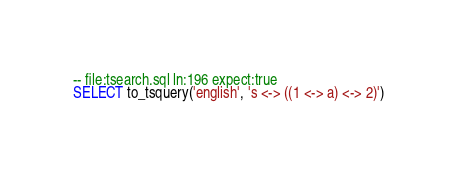<code> <loc_0><loc_0><loc_500><loc_500><_SQL_>-- file:tsearch.sql ln:196 expect:true
SELECT to_tsquery('english', 's <-> ((1 <-> a) <-> 2)')
</code> 